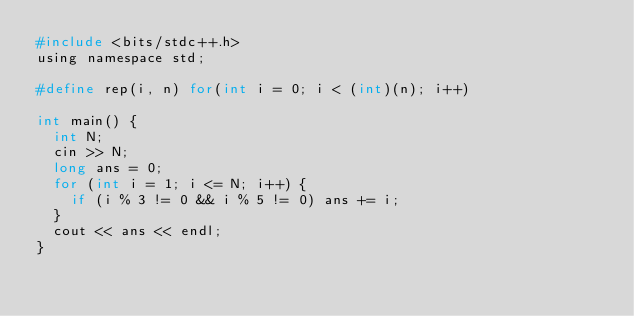<code> <loc_0><loc_0><loc_500><loc_500><_C_>#include <bits/stdc++.h>
using namespace std;

#define rep(i, n) for(int i = 0; i < (int)(n); i++)

int main() {
	int N;
	cin >> N;
	long ans = 0;
	for (int i = 1; i <= N; i++) {
		if (i % 3 != 0 && i % 5 != 0) ans += i;
	}
	cout << ans << endl;
}</code> 